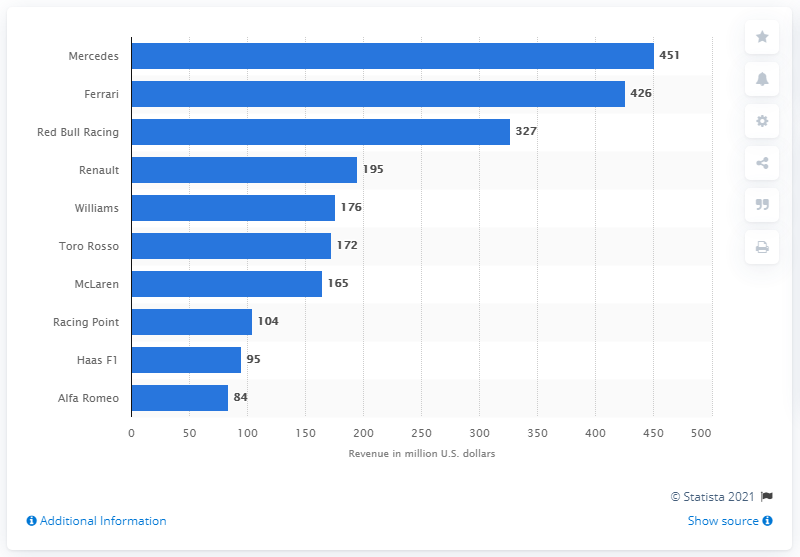List a handful of essential elements in this visual. In 2018, Mercedes generated approximately $451 million in revenue in the United States. 